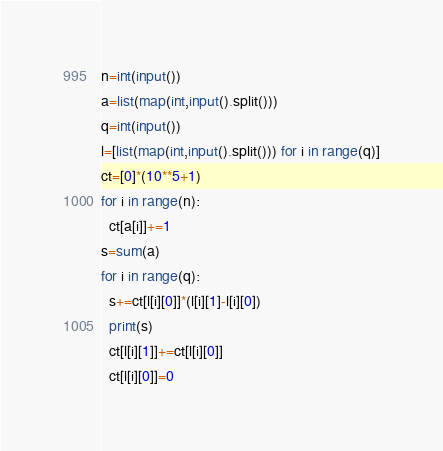Convert code to text. <code><loc_0><loc_0><loc_500><loc_500><_Python_>n=int(input())
a=list(map(int,input().split()))
q=int(input())
l=[list(map(int,input().split())) for i in range(q)]
ct=[0]*(10**5+1)
for i in range(n):
  ct[a[i]]+=1
s=sum(a)
for i in range(q):
  s+=ct[l[i][0]]*(l[i][1]-l[i][0])
  print(s)
  ct[l[i][1]]+=ct[l[i][0]]
  ct[l[i][0]]=0</code> 